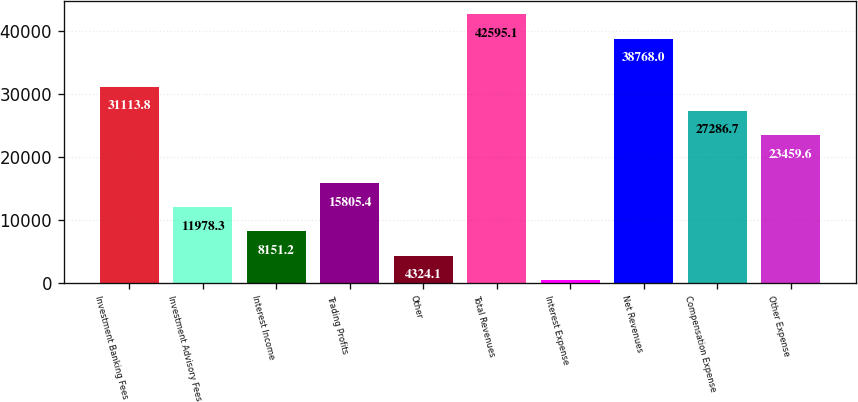Convert chart to OTSL. <chart><loc_0><loc_0><loc_500><loc_500><bar_chart><fcel>Investment Banking Fees<fcel>Investment Advisory Fees<fcel>Interest Income<fcel>Trading Profits<fcel>Other<fcel>Total Revenues<fcel>Interest Expense<fcel>Net Revenues<fcel>Compensation Expense<fcel>Other Expense<nl><fcel>31113.8<fcel>11978.3<fcel>8151.2<fcel>15805.4<fcel>4324.1<fcel>42595.1<fcel>497<fcel>38768<fcel>27286.7<fcel>23459.6<nl></chart> 